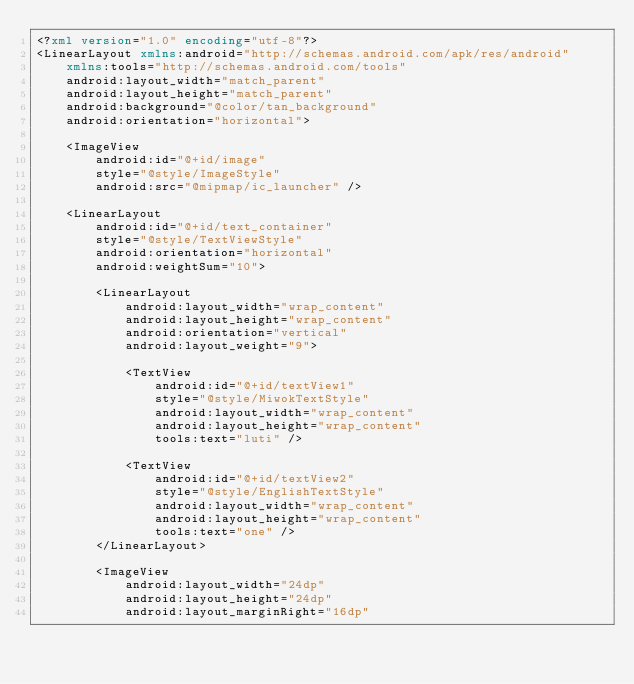Convert code to text. <code><loc_0><loc_0><loc_500><loc_500><_XML_><?xml version="1.0" encoding="utf-8"?>
<LinearLayout xmlns:android="http://schemas.android.com/apk/res/android"
    xmlns:tools="http://schemas.android.com/tools"
    android:layout_width="match_parent"
    android:layout_height="match_parent"
    android:background="@color/tan_background"
    android:orientation="horizontal">

    <ImageView
        android:id="@+id/image"
        style="@style/ImageStyle"
        android:src="@mipmap/ic_launcher" />

    <LinearLayout
        android:id="@+id/text_container"
        style="@style/TextViewStyle"
        android:orientation="horizontal"
        android:weightSum="10">

        <LinearLayout
            android:layout_width="wrap_content"
            android:layout_height="wrap_content"
            android:orientation="vertical"
            android:layout_weight="9">

            <TextView
                android:id="@+id/textView1"
                style="@style/MiwokTextStyle"
                android:layout_width="wrap_content"
                android:layout_height="wrap_content"
                tools:text="luti" />

            <TextView
                android:id="@+id/textView2"
                style="@style/EnglishTextStyle"
                android:layout_width="wrap_content"
                android:layout_height="wrap_content"
                tools:text="one" />
        </LinearLayout>

        <ImageView
            android:layout_width="24dp"
            android:layout_height="24dp"
            android:layout_marginRight="16dp"</code> 